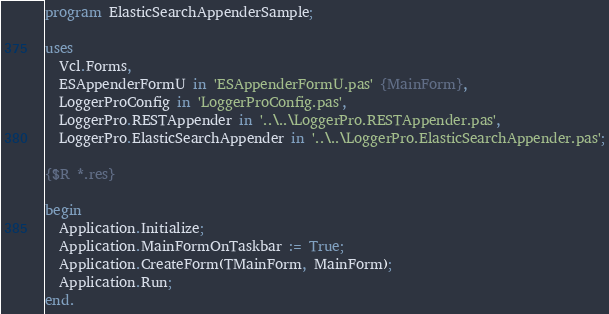Convert code to text. <code><loc_0><loc_0><loc_500><loc_500><_Pascal_>program ElasticSearchAppenderSample;

uses
  Vcl.Forms,
  ESAppenderFormU in 'ESAppenderFormU.pas' {MainForm},
  LoggerProConfig in 'LoggerProConfig.pas',
  LoggerPro.RESTAppender in '..\..\LoggerPro.RESTAppender.pas',
  LoggerPro.ElasticSearchAppender in '..\..\LoggerPro.ElasticSearchAppender.pas';

{$R *.res}

begin
  Application.Initialize;
  Application.MainFormOnTaskbar := True;
  Application.CreateForm(TMainForm, MainForm);
  Application.Run;
end.
</code> 